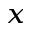Convert formula to latex. <formula><loc_0><loc_0><loc_500><loc_500>_ { x }</formula> 